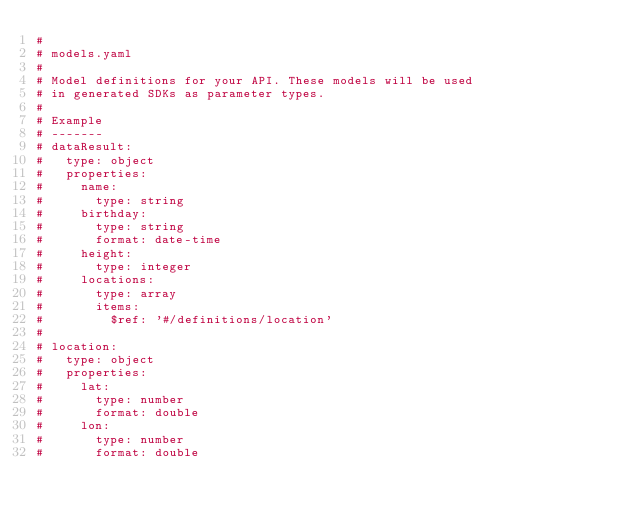Convert code to text. <code><loc_0><loc_0><loc_500><loc_500><_YAML_>#
# models.yaml
#
# Model definitions for your API. These models will be used
# in generated SDKs as parameter types.
#
# Example
# -------
# dataResult:
#   type: object
#   properties:
#     name:
#       type: string
#     birthday:
#       type: string
#       format: date-time
#     height:
#       type: integer
#     locations:
#       type: array
#       items:
#         $ref: '#/definitions/location'
#
# location:
#   type: object
#   properties:
#     lat:
#       type: number
#       format: double
#     lon:
#       type: number
#       format: double
</code> 